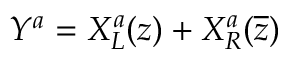Convert formula to latex. <formula><loc_0><loc_0><loc_500><loc_500>Y ^ { a } = X _ { L } ^ { a } ( z ) + X _ { R } ^ { a } ( \overline { z } )</formula> 